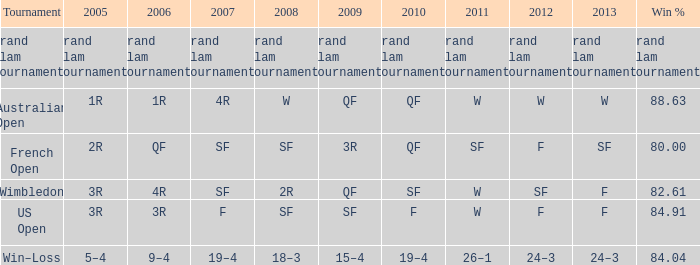What is the 2007-based "f" value in the year 2008? SF. 